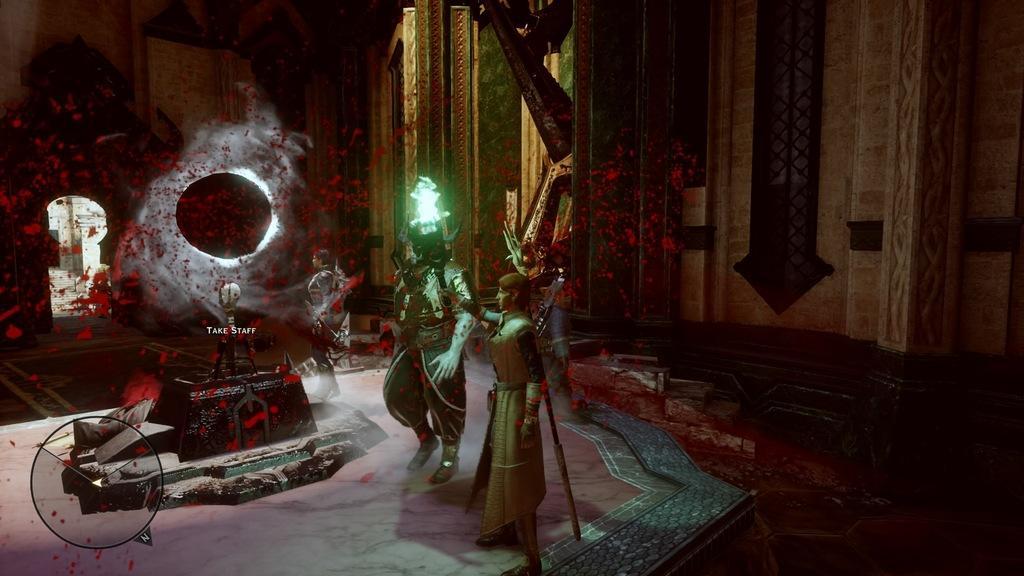Please provide a concise description of this image. This is an animated image, there are three persons, there is an object on the floor, there is text on the object, there is a wall towards the top of the image, there is a carpet on the floor, there is a wall towards the left of the image. 